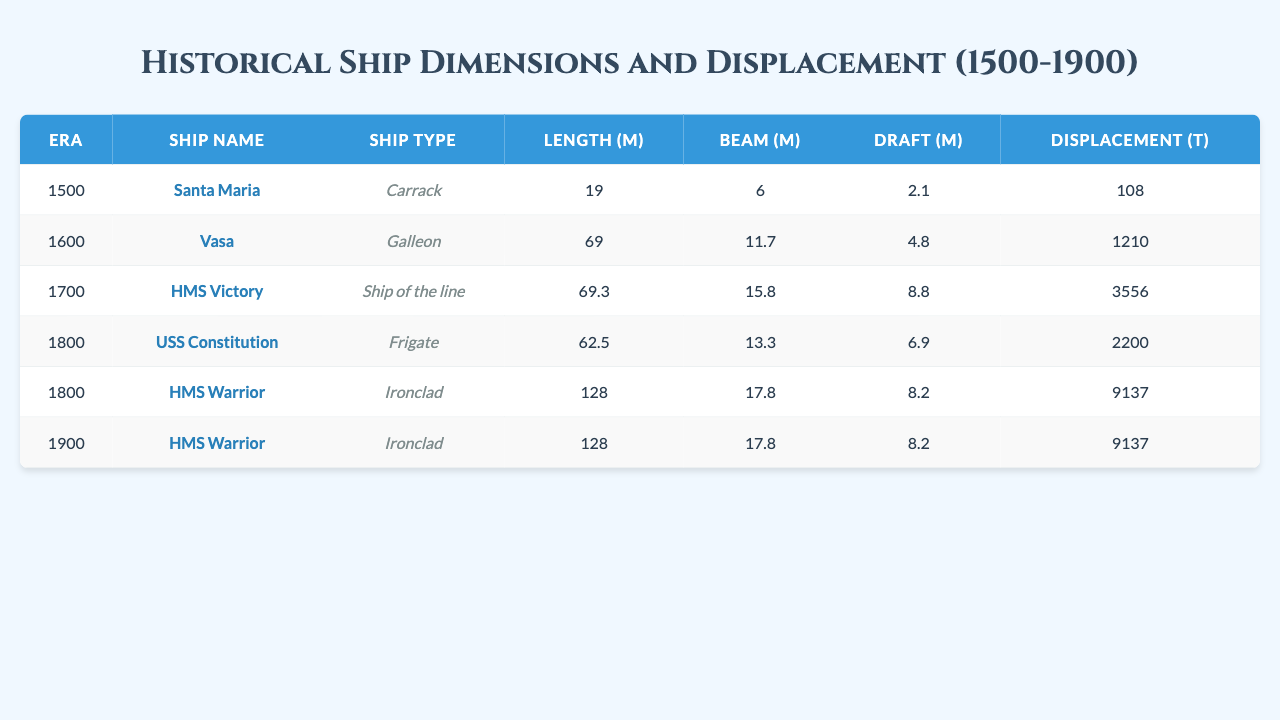What ship had the largest length in the 1800 era? In the 1800 era, the table lists the USS Constitution (62.5 m) and HMS Warrior (128 m). The HMS Warrior has the largest length among these two ships.
Answer: HMS Warrior What is the beam of the Vasa? The beam of the Vasa is listed in the table as 11.7 meters.
Answer: 11.7 m Which ship had a displacement of 2200 tons? Referring to the table, the USS Constitution has a displacement of 2200 tons, as indicated in the data.
Answer: USS Constitution Was there any ship recorded in the 1600 era with a draft greater than 4 meters? The draft of the Vasa in the 1600 era is recorded as 4.8 meters. Hence, it is true that there was a ship with a draft greater than 4 meters.
Answer: Yes What is the average displacement of the ships from both the 1800 and 1900 eras? Ships in the 1800 era (USS Constitution: 2200 t, HMS Warrior: 9137 t) have a total displacement of 11337 t; in the 1900 era, the HMS Warrior contributes another 9137 t. Thus, the combined total of 20474 t from 3 ships gives an average displacement of 20474/3 = 6824.67 t.
Answer: 6825 t Is the length of the HMS Victory greater than that of the Santa Maria? The HMS Victory has a length of 69.3 meters while the Santa Maria has a length of 19 meters, confirming that the HMS Victory is longer.
Answer: Yes What was the draft of the HMS Warrior and how does it compare to the draft of the Vasa? The HMS Warrior's draft is 8.2 meters compared to the Vasa's draft of 4.8 meters. Therefore, the HMS Warrior's draft is significantly greater.
Answer: 8.2 m, greater than Vasa Which ship was classified as a frigate and what was its length? The USS Constitution is classified as a frigate, and its length is recorded as 62.5 meters in the table.
Answer: USS Constitution, 62.5 m How many ships recorded in the table were from the 1700 era? There is only one ship from the 1700 era, the HMS Victory, as per the listed data.
Answer: 1 What is the draft of the oldest recorded ship in the data? The oldest ship recorded in the data is the Santa Maria from the 1500 era, which has a draft of 2.1 meters.
Answer: 2.1 m 